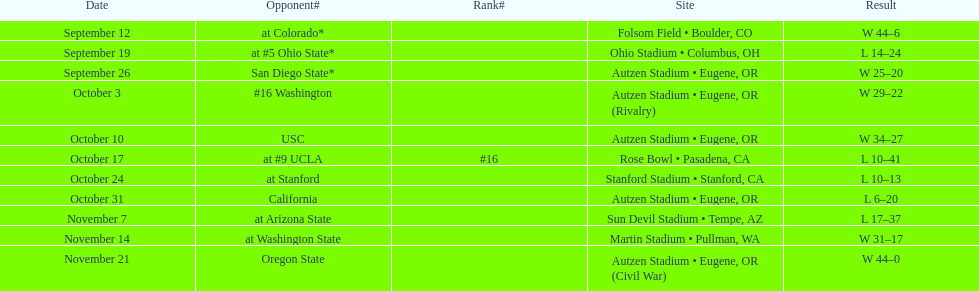Who was the final adversary they faced in the season? Oregon State. 